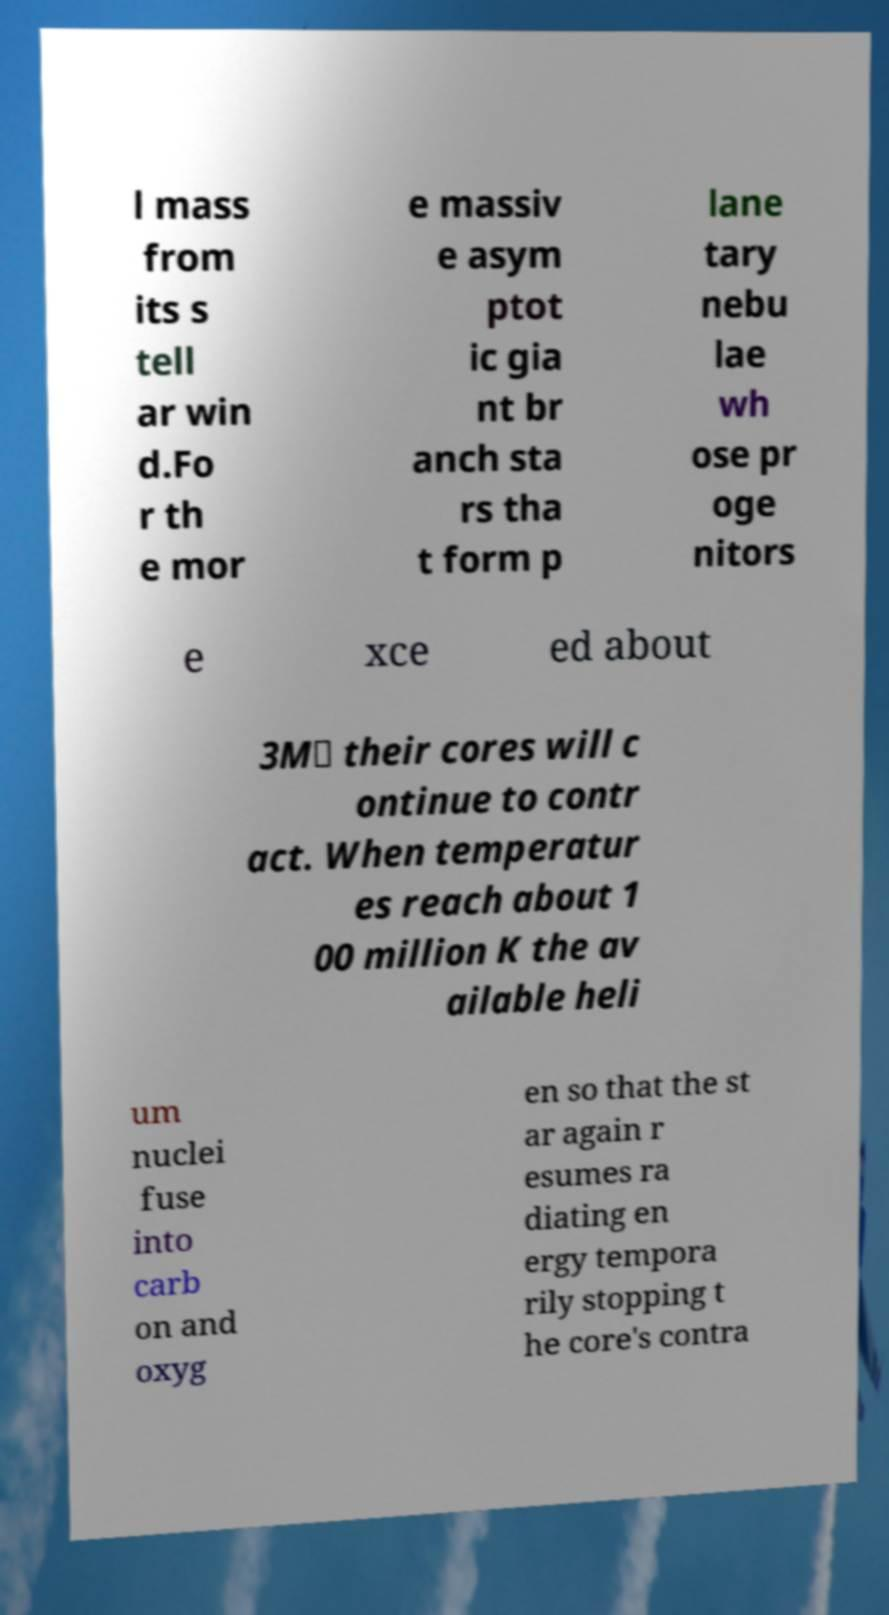Can you read and provide the text displayed in the image?This photo seems to have some interesting text. Can you extract and type it out for me? l mass from its s tell ar win d.Fo r th e mor e massiv e asym ptot ic gia nt br anch sta rs tha t form p lane tary nebu lae wh ose pr oge nitors e xce ed about 3M⊙ their cores will c ontinue to contr act. When temperatur es reach about 1 00 million K the av ailable heli um nuclei fuse into carb on and oxyg en so that the st ar again r esumes ra diating en ergy tempora rily stopping t he core's contra 